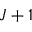Convert formula to latex. <formula><loc_0><loc_0><loc_500><loc_500>J + 1</formula> 